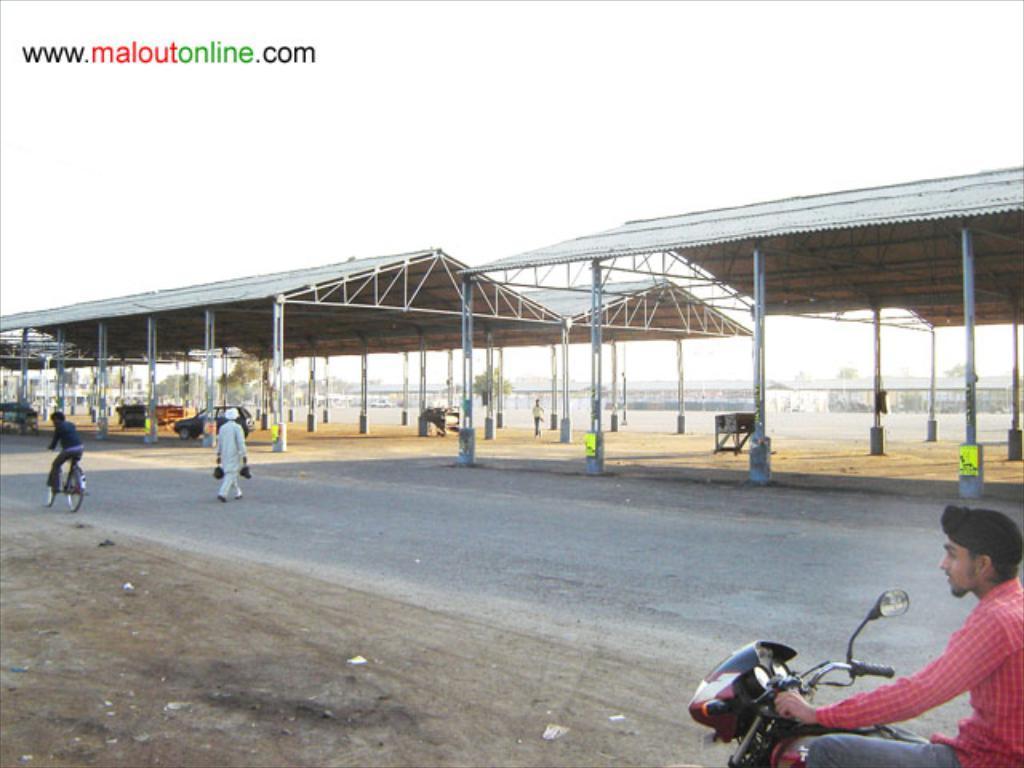Please provide a concise description of this image. In this Image I see a man who is on the cycle and this man walking on the road, this man who is on the bike and I see this man over here. In the background i see the sheds, a car over here. 